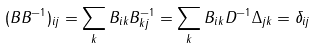Convert formula to latex. <formula><loc_0><loc_0><loc_500><loc_500>( B B ^ { - 1 } ) _ { i j } = \sum _ { k } B _ { i k } B ^ { - 1 } _ { k j } = \sum _ { k } B _ { i k } D ^ { - 1 } \Delta _ { j k } = \delta _ { i j }</formula> 